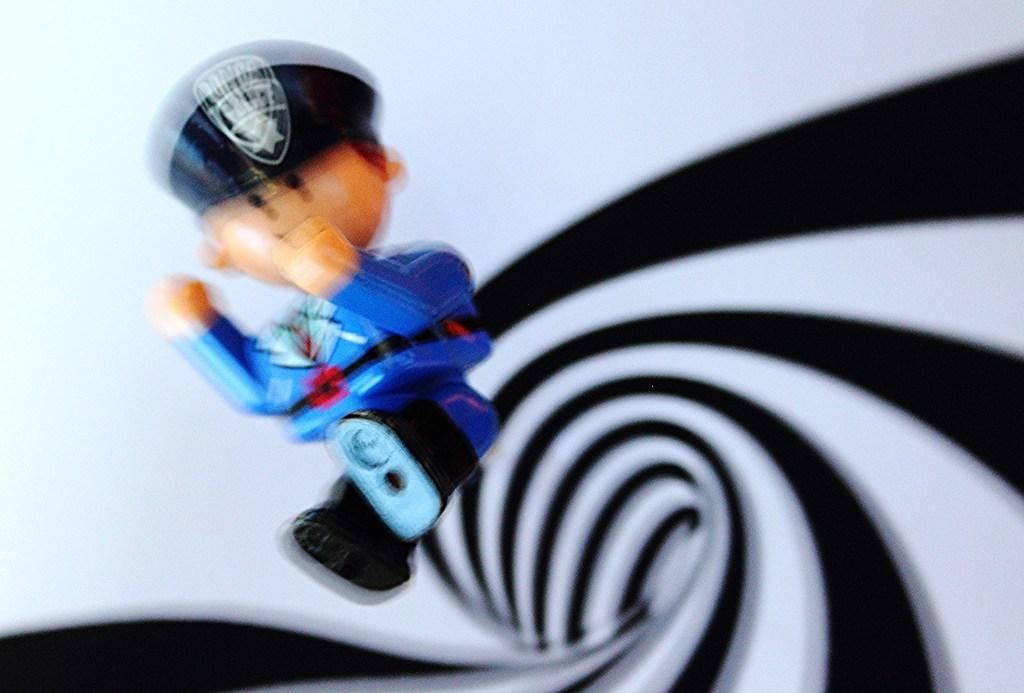What type of image is being described? The image is animated. What object can be seen in the image? There is a toy in the image. What type of cake is being served in the image? There is no cake present in the image; it is an animated image with a toy. What activity is the person in the image engaged in? The image is animated and does not depict a person, so there is no activity to describe. 